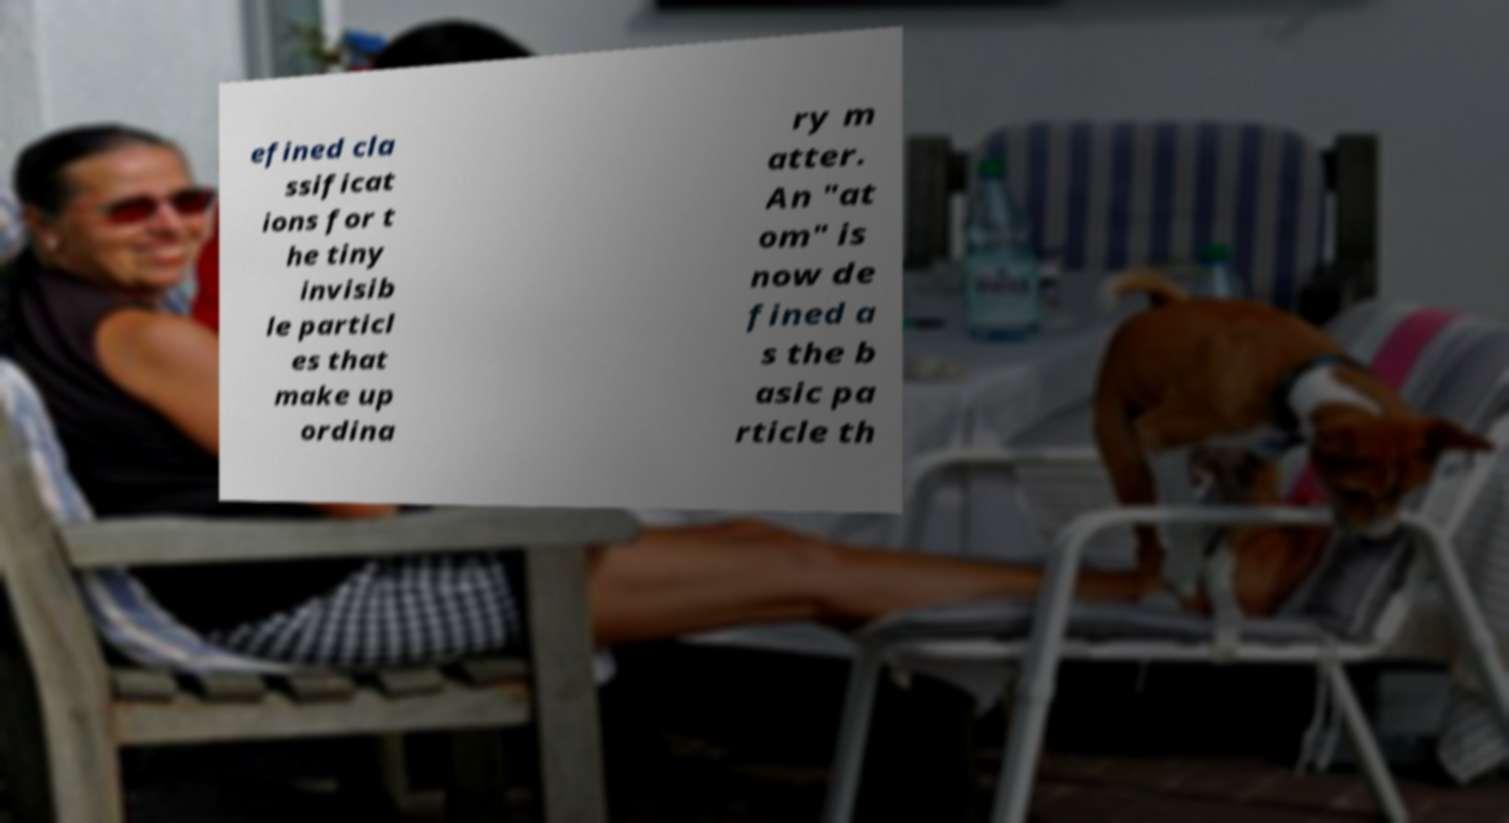Could you assist in decoding the text presented in this image and type it out clearly? efined cla ssificat ions for t he tiny invisib le particl es that make up ordina ry m atter. An "at om" is now de fined a s the b asic pa rticle th 